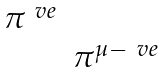Convert formula to latex. <formula><loc_0><loc_0><loc_500><loc_500>\begin{matrix} \pi ^ { \ v e } & \\ & \pi ^ { \mu - \ v e } \end{matrix}</formula> 